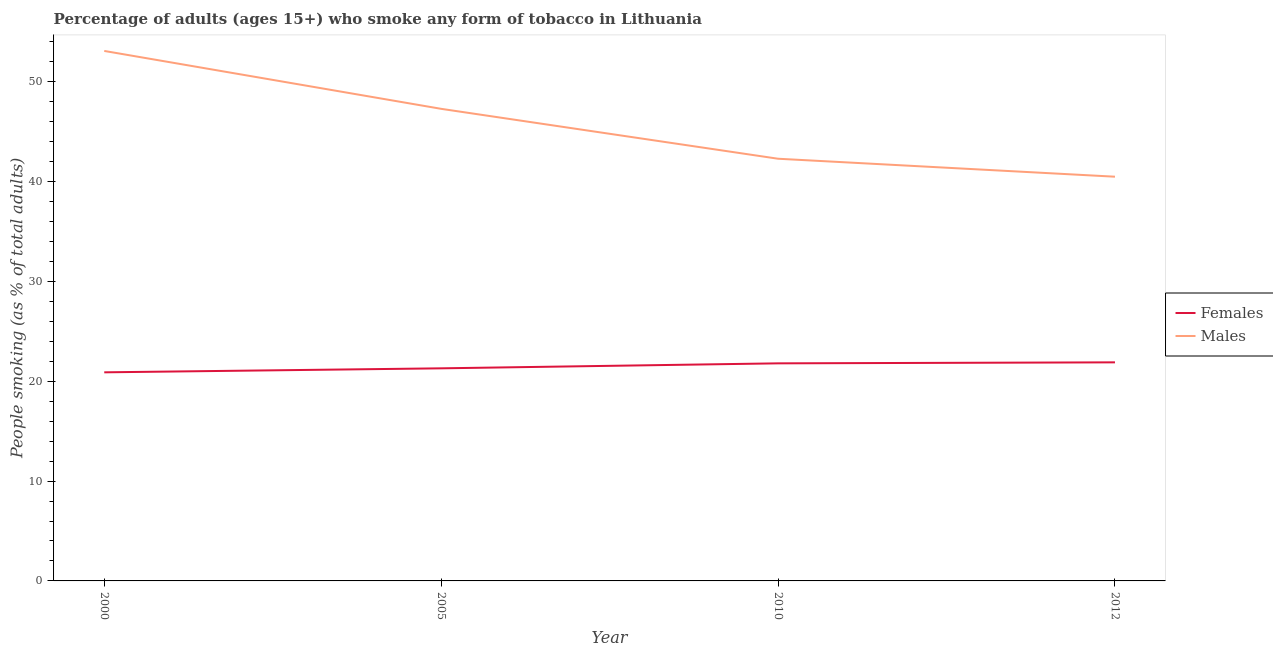Does the line corresponding to percentage of females who smoke intersect with the line corresponding to percentage of males who smoke?
Provide a short and direct response. No. What is the percentage of males who smoke in 2012?
Your answer should be very brief. 40.5. Across all years, what is the maximum percentage of males who smoke?
Ensure brevity in your answer.  53.1. Across all years, what is the minimum percentage of females who smoke?
Your response must be concise. 20.9. What is the total percentage of females who smoke in the graph?
Provide a succinct answer. 85.9. What is the difference between the percentage of females who smoke in 2010 and that in 2012?
Give a very brief answer. -0.1. What is the difference between the percentage of females who smoke in 2005 and the percentage of males who smoke in 2000?
Your answer should be compact. -31.8. What is the average percentage of males who smoke per year?
Offer a terse response. 45.8. In the year 2005, what is the difference between the percentage of males who smoke and percentage of females who smoke?
Keep it short and to the point. 26. In how many years, is the percentage of females who smoke greater than 30 %?
Offer a terse response. 0. What is the ratio of the percentage of females who smoke in 2000 to that in 2005?
Make the answer very short. 0.98. Is the difference between the percentage of males who smoke in 2000 and 2005 greater than the difference between the percentage of females who smoke in 2000 and 2005?
Your answer should be very brief. Yes. What is the difference between the highest and the second highest percentage of males who smoke?
Keep it short and to the point. 5.8. What is the difference between the highest and the lowest percentage of females who smoke?
Keep it short and to the point. 1. Is the sum of the percentage of males who smoke in 2005 and 2010 greater than the maximum percentage of females who smoke across all years?
Provide a succinct answer. Yes. Is the percentage of females who smoke strictly greater than the percentage of males who smoke over the years?
Provide a succinct answer. No. Is the percentage of males who smoke strictly less than the percentage of females who smoke over the years?
Give a very brief answer. No. How many years are there in the graph?
Your answer should be very brief. 4. What is the difference between two consecutive major ticks on the Y-axis?
Offer a terse response. 10. Are the values on the major ticks of Y-axis written in scientific E-notation?
Your answer should be very brief. No. Does the graph contain any zero values?
Ensure brevity in your answer.  No. Where does the legend appear in the graph?
Offer a very short reply. Center right. How many legend labels are there?
Offer a terse response. 2. How are the legend labels stacked?
Make the answer very short. Vertical. What is the title of the graph?
Your answer should be compact. Percentage of adults (ages 15+) who smoke any form of tobacco in Lithuania. What is the label or title of the X-axis?
Keep it short and to the point. Year. What is the label or title of the Y-axis?
Your response must be concise. People smoking (as % of total adults). What is the People smoking (as % of total adults) of Females in 2000?
Give a very brief answer. 20.9. What is the People smoking (as % of total adults) in Males in 2000?
Your answer should be very brief. 53.1. What is the People smoking (as % of total adults) of Females in 2005?
Provide a succinct answer. 21.3. What is the People smoking (as % of total adults) of Males in 2005?
Your response must be concise. 47.3. What is the People smoking (as % of total adults) in Females in 2010?
Keep it short and to the point. 21.8. What is the People smoking (as % of total adults) of Males in 2010?
Offer a terse response. 42.3. What is the People smoking (as % of total adults) of Females in 2012?
Offer a very short reply. 21.9. What is the People smoking (as % of total adults) in Males in 2012?
Provide a succinct answer. 40.5. Across all years, what is the maximum People smoking (as % of total adults) of Females?
Your response must be concise. 21.9. Across all years, what is the maximum People smoking (as % of total adults) in Males?
Your response must be concise. 53.1. Across all years, what is the minimum People smoking (as % of total adults) of Females?
Your answer should be very brief. 20.9. Across all years, what is the minimum People smoking (as % of total adults) in Males?
Your answer should be very brief. 40.5. What is the total People smoking (as % of total adults) in Females in the graph?
Give a very brief answer. 85.9. What is the total People smoking (as % of total adults) of Males in the graph?
Provide a short and direct response. 183.2. What is the difference between the People smoking (as % of total adults) of Females in 2000 and that in 2005?
Ensure brevity in your answer.  -0.4. What is the difference between the People smoking (as % of total adults) in Males in 2000 and that in 2005?
Make the answer very short. 5.8. What is the difference between the People smoking (as % of total adults) in Females in 2000 and that in 2010?
Ensure brevity in your answer.  -0.9. What is the difference between the People smoking (as % of total adults) in Males in 2000 and that in 2010?
Ensure brevity in your answer.  10.8. What is the difference between the People smoking (as % of total adults) of Males in 2000 and that in 2012?
Your response must be concise. 12.6. What is the difference between the People smoking (as % of total adults) of Females in 2005 and that in 2010?
Make the answer very short. -0.5. What is the difference between the People smoking (as % of total adults) of Females in 2005 and that in 2012?
Offer a very short reply. -0.6. What is the difference between the People smoking (as % of total adults) in Males in 2010 and that in 2012?
Provide a succinct answer. 1.8. What is the difference between the People smoking (as % of total adults) in Females in 2000 and the People smoking (as % of total adults) in Males in 2005?
Make the answer very short. -26.4. What is the difference between the People smoking (as % of total adults) of Females in 2000 and the People smoking (as % of total adults) of Males in 2010?
Your response must be concise. -21.4. What is the difference between the People smoking (as % of total adults) of Females in 2000 and the People smoking (as % of total adults) of Males in 2012?
Ensure brevity in your answer.  -19.6. What is the difference between the People smoking (as % of total adults) of Females in 2005 and the People smoking (as % of total adults) of Males in 2010?
Make the answer very short. -21. What is the difference between the People smoking (as % of total adults) in Females in 2005 and the People smoking (as % of total adults) in Males in 2012?
Make the answer very short. -19.2. What is the difference between the People smoking (as % of total adults) of Females in 2010 and the People smoking (as % of total adults) of Males in 2012?
Provide a succinct answer. -18.7. What is the average People smoking (as % of total adults) in Females per year?
Provide a short and direct response. 21.48. What is the average People smoking (as % of total adults) of Males per year?
Provide a succinct answer. 45.8. In the year 2000, what is the difference between the People smoking (as % of total adults) of Females and People smoking (as % of total adults) of Males?
Provide a short and direct response. -32.2. In the year 2005, what is the difference between the People smoking (as % of total adults) in Females and People smoking (as % of total adults) in Males?
Offer a very short reply. -26. In the year 2010, what is the difference between the People smoking (as % of total adults) of Females and People smoking (as % of total adults) of Males?
Ensure brevity in your answer.  -20.5. In the year 2012, what is the difference between the People smoking (as % of total adults) of Females and People smoking (as % of total adults) of Males?
Ensure brevity in your answer.  -18.6. What is the ratio of the People smoking (as % of total adults) in Females in 2000 to that in 2005?
Your answer should be very brief. 0.98. What is the ratio of the People smoking (as % of total adults) in Males in 2000 to that in 2005?
Provide a succinct answer. 1.12. What is the ratio of the People smoking (as % of total adults) of Females in 2000 to that in 2010?
Provide a succinct answer. 0.96. What is the ratio of the People smoking (as % of total adults) in Males in 2000 to that in 2010?
Ensure brevity in your answer.  1.26. What is the ratio of the People smoking (as % of total adults) of Females in 2000 to that in 2012?
Make the answer very short. 0.95. What is the ratio of the People smoking (as % of total adults) of Males in 2000 to that in 2012?
Make the answer very short. 1.31. What is the ratio of the People smoking (as % of total adults) in Females in 2005 to that in 2010?
Provide a succinct answer. 0.98. What is the ratio of the People smoking (as % of total adults) in Males in 2005 to that in 2010?
Provide a short and direct response. 1.12. What is the ratio of the People smoking (as % of total adults) of Females in 2005 to that in 2012?
Offer a very short reply. 0.97. What is the ratio of the People smoking (as % of total adults) of Males in 2005 to that in 2012?
Your response must be concise. 1.17. What is the ratio of the People smoking (as % of total adults) of Females in 2010 to that in 2012?
Provide a succinct answer. 1. What is the ratio of the People smoking (as % of total adults) of Males in 2010 to that in 2012?
Your response must be concise. 1.04. What is the difference between the highest and the second highest People smoking (as % of total adults) of Females?
Keep it short and to the point. 0.1. What is the difference between the highest and the second highest People smoking (as % of total adults) in Males?
Your answer should be compact. 5.8. 